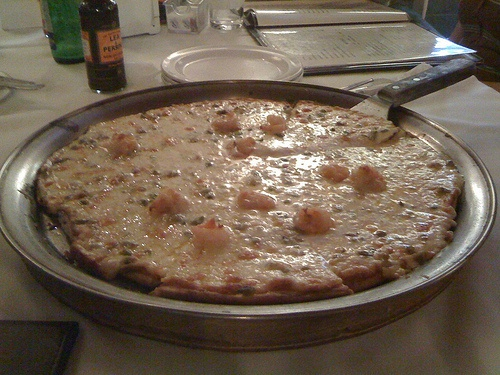Describe the objects in this image and their specific colors. I can see dining table in black, gray, and darkgray tones, pizza in gray and maroon tones, book in gray and darkgray tones, knife in gray, black, and darkgray tones, and bottle in gray, black, maroon, and brown tones in this image. 